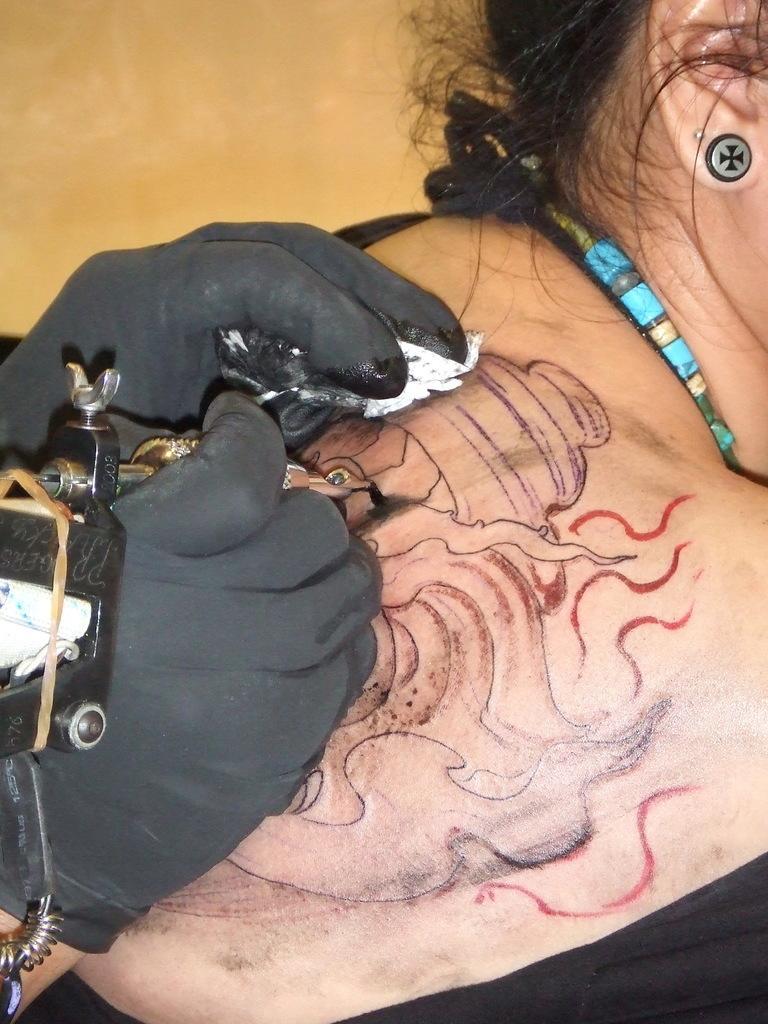Can you describe this image briefly? This picture shows a human piercing tattoo on the woman back and we see a stud to the ear and a ornament in the woman neck and we see a tattoo machine in the human hands. 